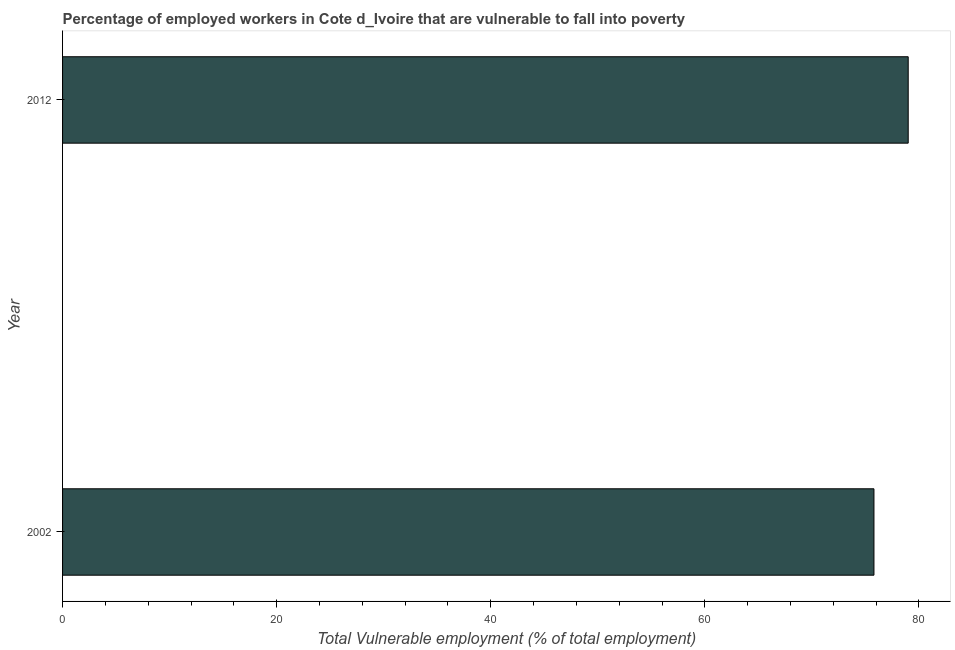Does the graph contain grids?
Offer a terse response. No. What is the title of the graph?
Ensure brevity in your answer.  Percentage of employed workers in Cote d_Ivoire that are vulnerable to fall into poverty. What is the label or title of the X-axis?
Your response must be concise. Total Vulnerable employment (% of total employment). What is the total vulnerable employment in 2012?
Keep it short and to the point. 79. Across all years, what is the maximum total vulnerable employment?
Provide a succinct answer. 79. Across all years, what is the minimum total vulnerable employment?
Offer a very short reply. 75.8. In which year was the total vulnerable employment maximum?
Your answer should be compact. 2012. What is the sum of the total vulnerable employment?
Make the answer very short. 154.8. What is the difference between the total vulnerable employment in 2002 and 2012?
Provide a succinct answer. -3.2. What is the average total vulnerable employment per year?
Your answer should be compact. 77.4. What is the median total vulnerable employment?
Keep it short and to the point. 77.4. How many bars are there?
Your answer should be compact. 2. What is the difference between two consecutive major ticks on the X-axis?
Make the answer very short. 20. Are the values on the major ticks of X-axis written in scientific E-notation?
Make the answer very short. No. What is the Total Vulnerable employment (% of total employment) of 2002?
Give a very brief answer. 75.8. What is the Total Vulnerable employment (% of total employment) of 2012?
Provide a short and direct response. 79. What is the ratio of the Total Vulnerable employment (% of total employment) in 2002 to that in 2012?
Make the answer very short. 0.96. 